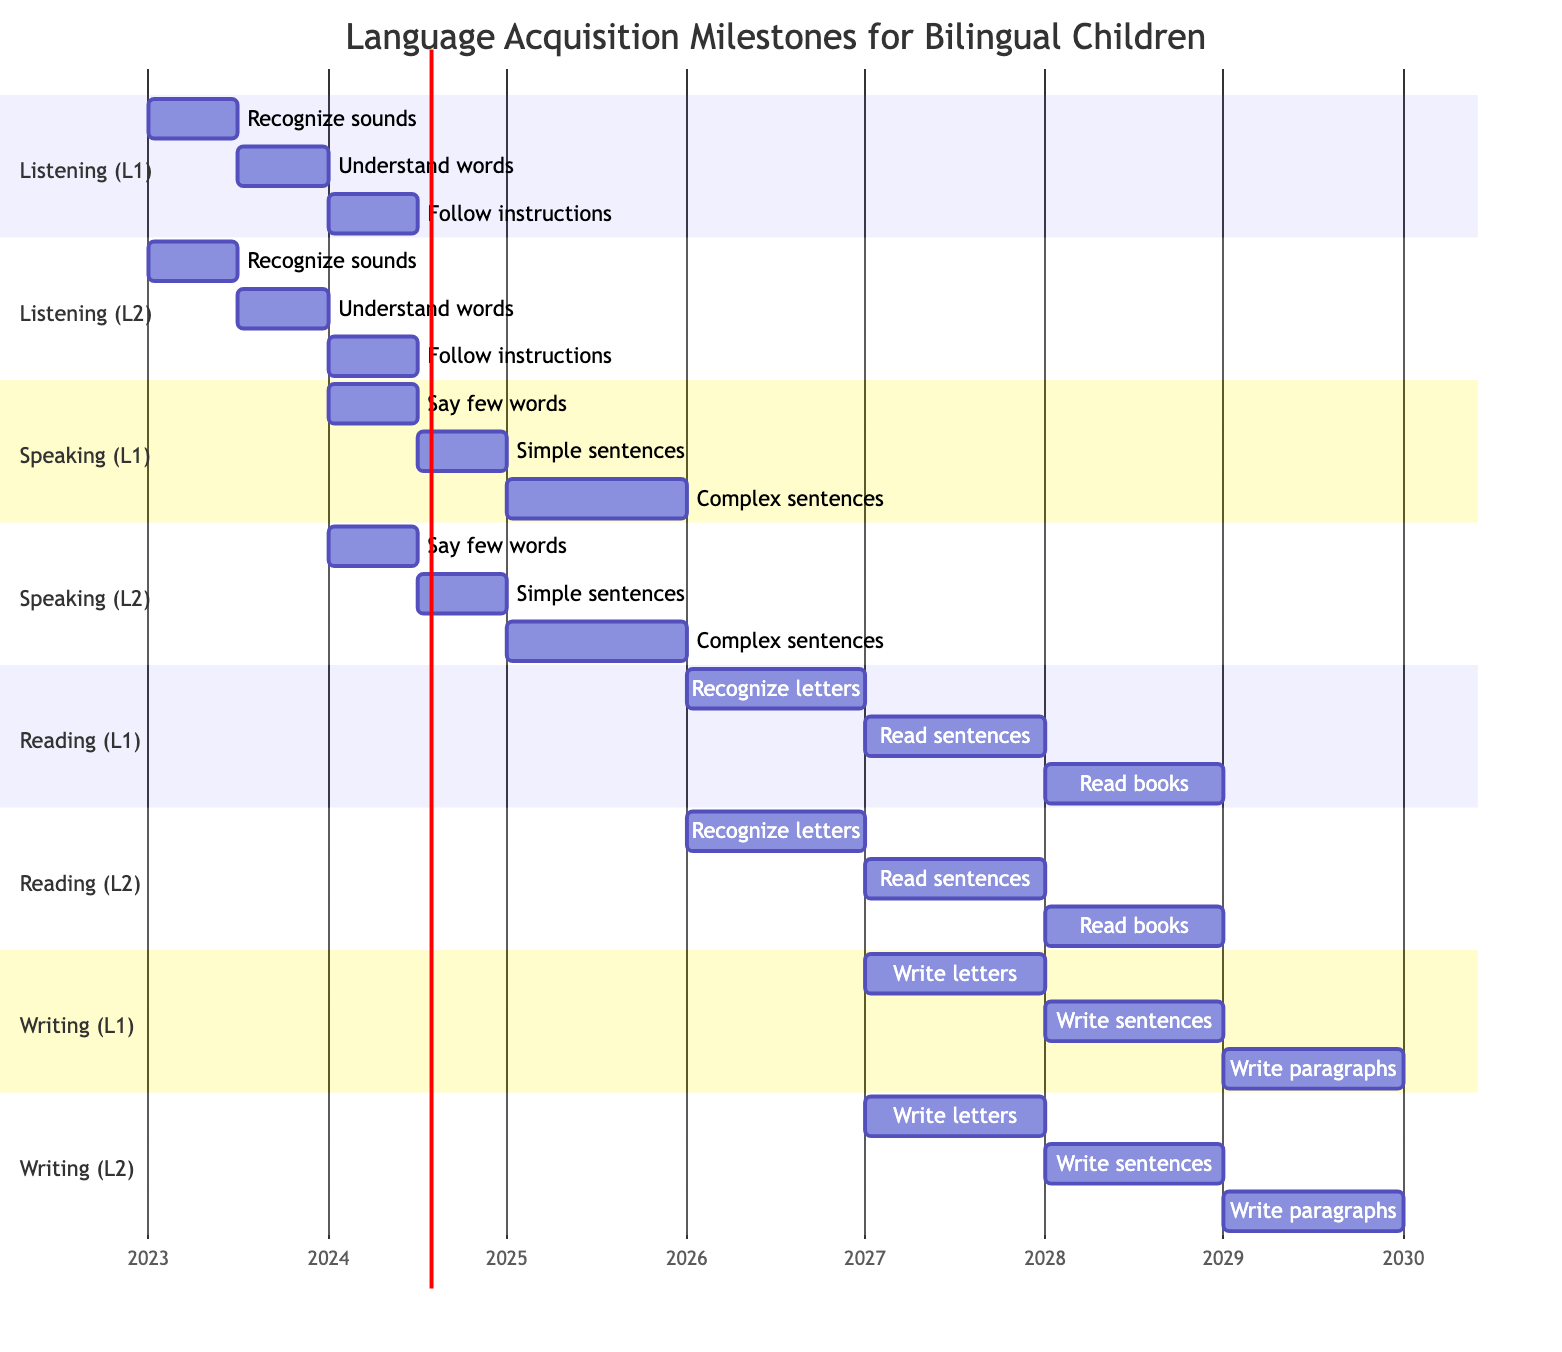What's the age range for recognizing sounds in both languages? The diagram shows the milestone for recognizing sounds in both Language 1 and Language 2 spans from 0 to 6 months.
Answer: 0-6 months How many milestones are listed for speaking in Language 1? The diagram indicates there are three milestones for speaking skills in Language 1: saying few words, forming simple sentences, and using complex sentences.
Answer: 3 What is the first milestone for writing in Language 2? According to the diagram, the first milestone for writing in Language 2 is writing letters, starting at the age of 4-5 years.
Answer: Write letters At what age do both languages have a milestone for following instructions in listening skills? The diagram states that both languages have a milestone for following instructions at 12-18 months, as indicated in the listening skills sections.
Answer: 12-18 months Which milestone occurs last in the writing skill section for both languages? In the writing skill sections for both languages, the final milestone listed is writing paragraphs, which occurs after writing sentences at the age of 6-7 years.
Answer: Write paragraphs How long will it take to reach the speaking skill of using complex sentences in Language 2? The diagram indicates that the speaking skill milestone for using complex sentences in Language 2 begins at the age of 2-3 years and lasts until the age of 3 years, making it a 12-month period.
Answer: 12 months What skill has milestones beginning earlier, listening or reading in Language 1? By examining the diagram, it is evident that listening milestones begin at 0-6 months, while reading milestones start at age 3-4 years, indicating that listening skills develop earlier than reading skills in Language 1.
Answer: Listening In total, how many milestones are presented for reading skills across both languages? The diagram shows three milestones for reading skills for Language 1 and three for Language 2, resulting in a total of six milestones presented for reading skills across both languages.
Answer: 6 